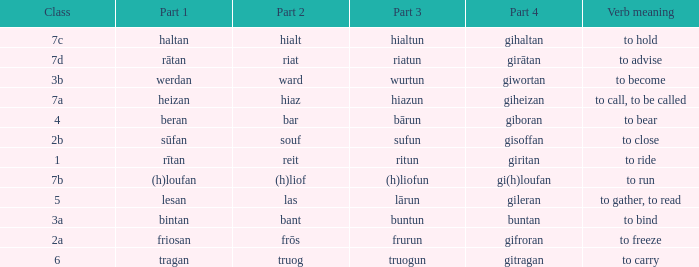What class in the word with part 4 "giheizan"? 7a. 